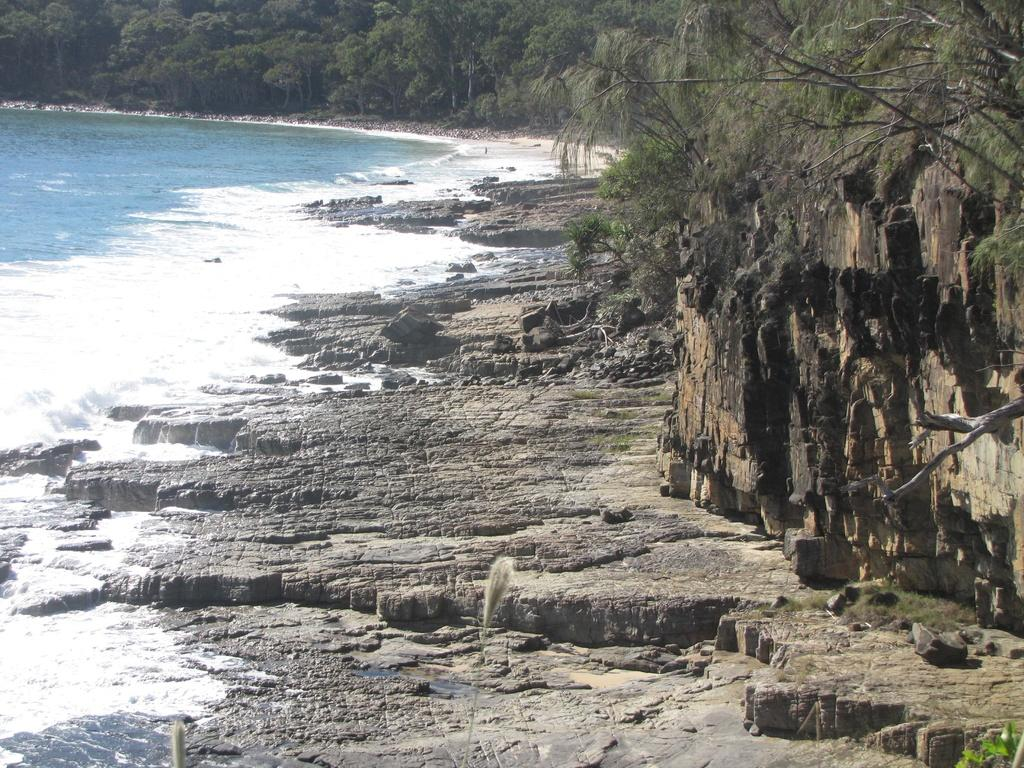What is located on the left side of the image? There is water on the left side of the image. What can be found on the right side of the image? There are stones on the ground on the right side of the image. What type of vegetation is present in the image? There are plants in the image. What can be seen in the background of the image? There are trees in the background of the image. Can you tell me where the kitten is playing with the doctor in the image? There is no kitten or doctor present in the image. How many hands are visible in the image? There is no mention of hands in the provided facts, so we cannot determine the number of hands visible in the image. 